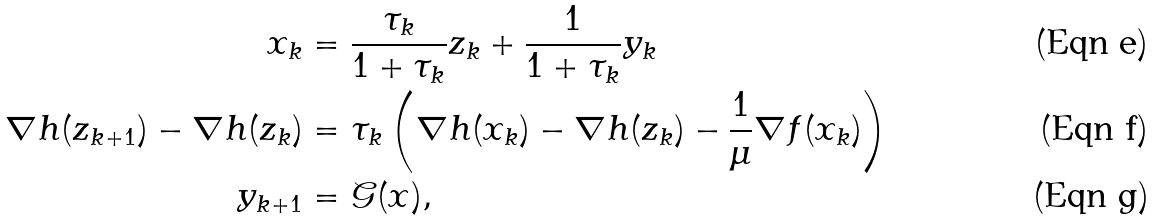<formula> <loc_0><loc_0><loc_500><loc_500>x _ { k } & = \frac { \tau _ { k } } { 1 + \tau _ { k } } z _ { k } + \frac { 1 } { 1 + \tau _ { k } } y _ { k } \\ \nabla h ( z _ { k + 1 } ) - \nabla h ( z _ { k } ) & = \tau _ { k } \left ( \nabla h ( x _ { k } ) - \nabla h ( z _ { k } ) - \frac { 1 } { \mu } \nabla f ( x _ { k } ) \right ) \\ y _ { k + 1 } & = \mathcal { G } ( x ) ,</formula> 